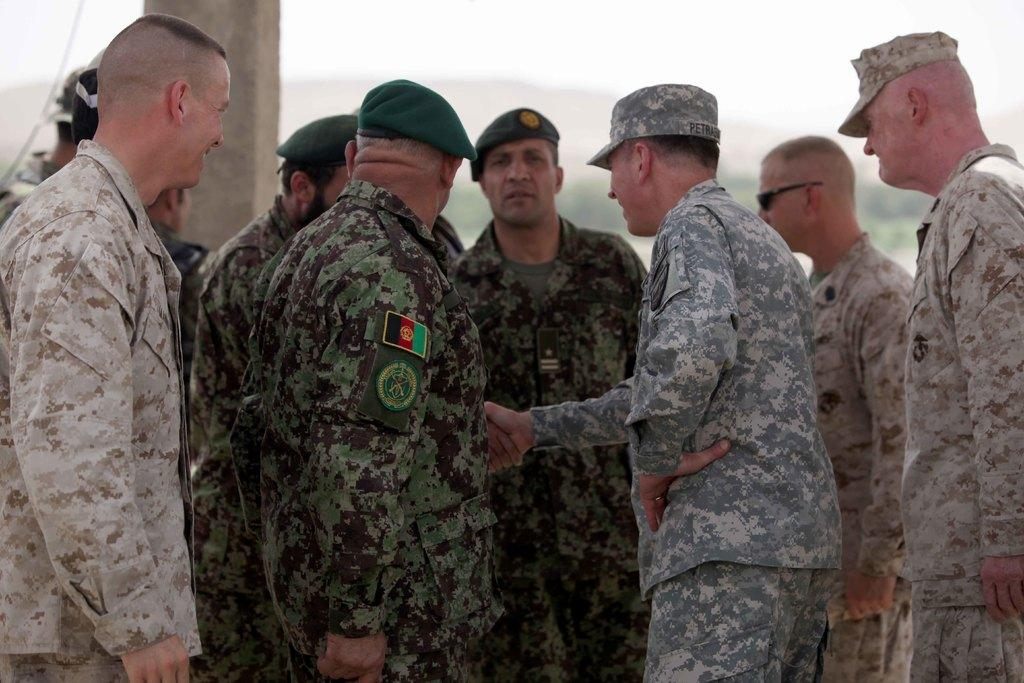How many people are in the image? There is a group of persons in the image, but the exact number is not specified. Where are the persons located in the image? The group of persons is standing in the middle of the image. What is beside the group of persons? There is a pillar beside the group of persons. What type of toys can be seen on the ground near the group of persons? There is no mention of toys in the image, so we cannot answer this question. 